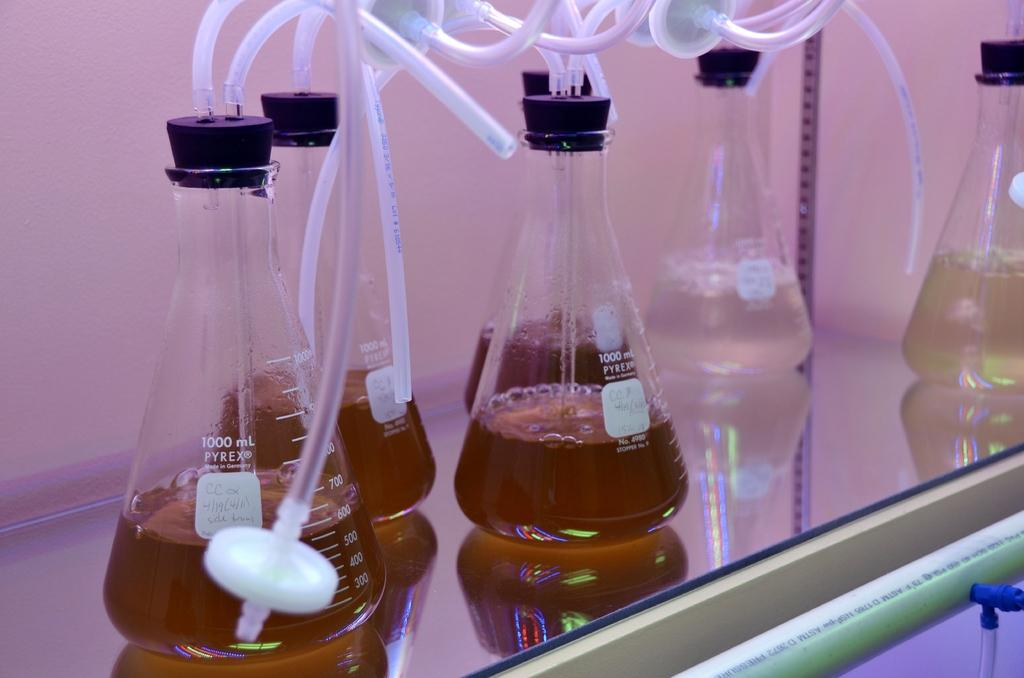<image>
Present a compact description of the photo's key features. One thousand milliliter beakers sit on a table with tubes coming out of them. 